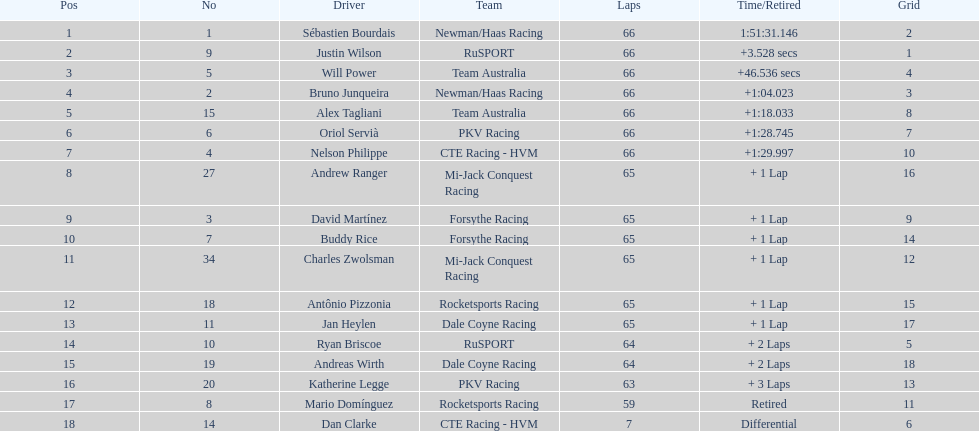Rice finished 10th. who finished next? Charles Zwolsman. 